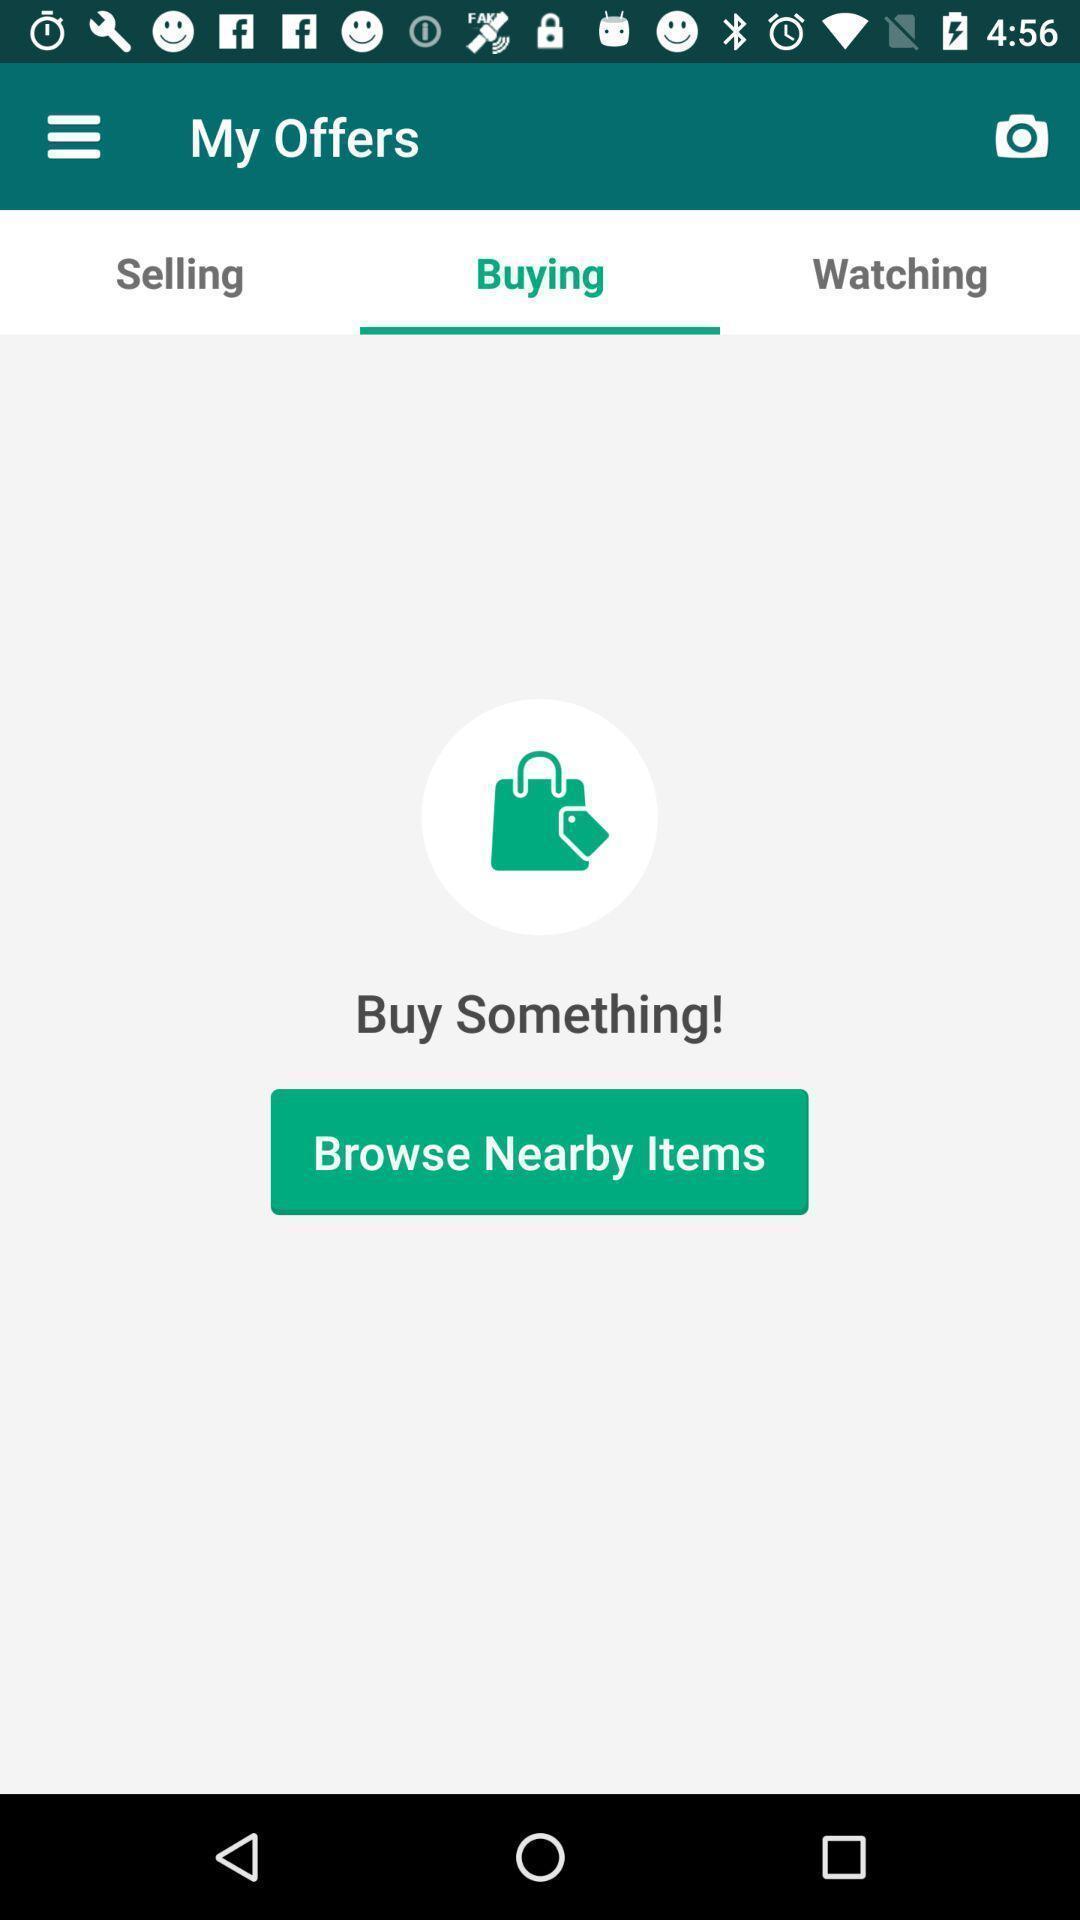Summarize the main components in this picture. Window displaying a app for local buyers and sellers. 